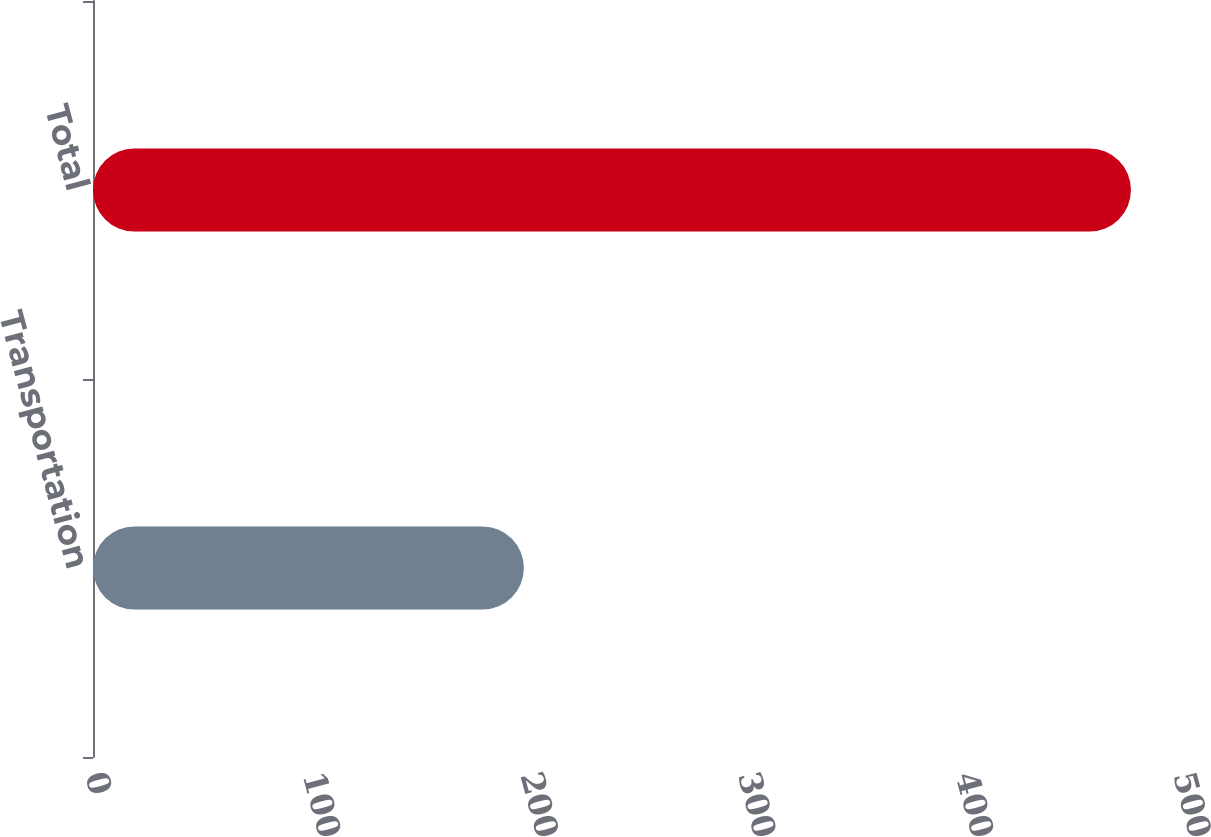Convert chart. <chart><loc_0><loc_0><loc_500><loc_500><bar_chart><fcel>Transportation<fcel>Total<nl><fcel>198<fcel>477<nl></chart> 